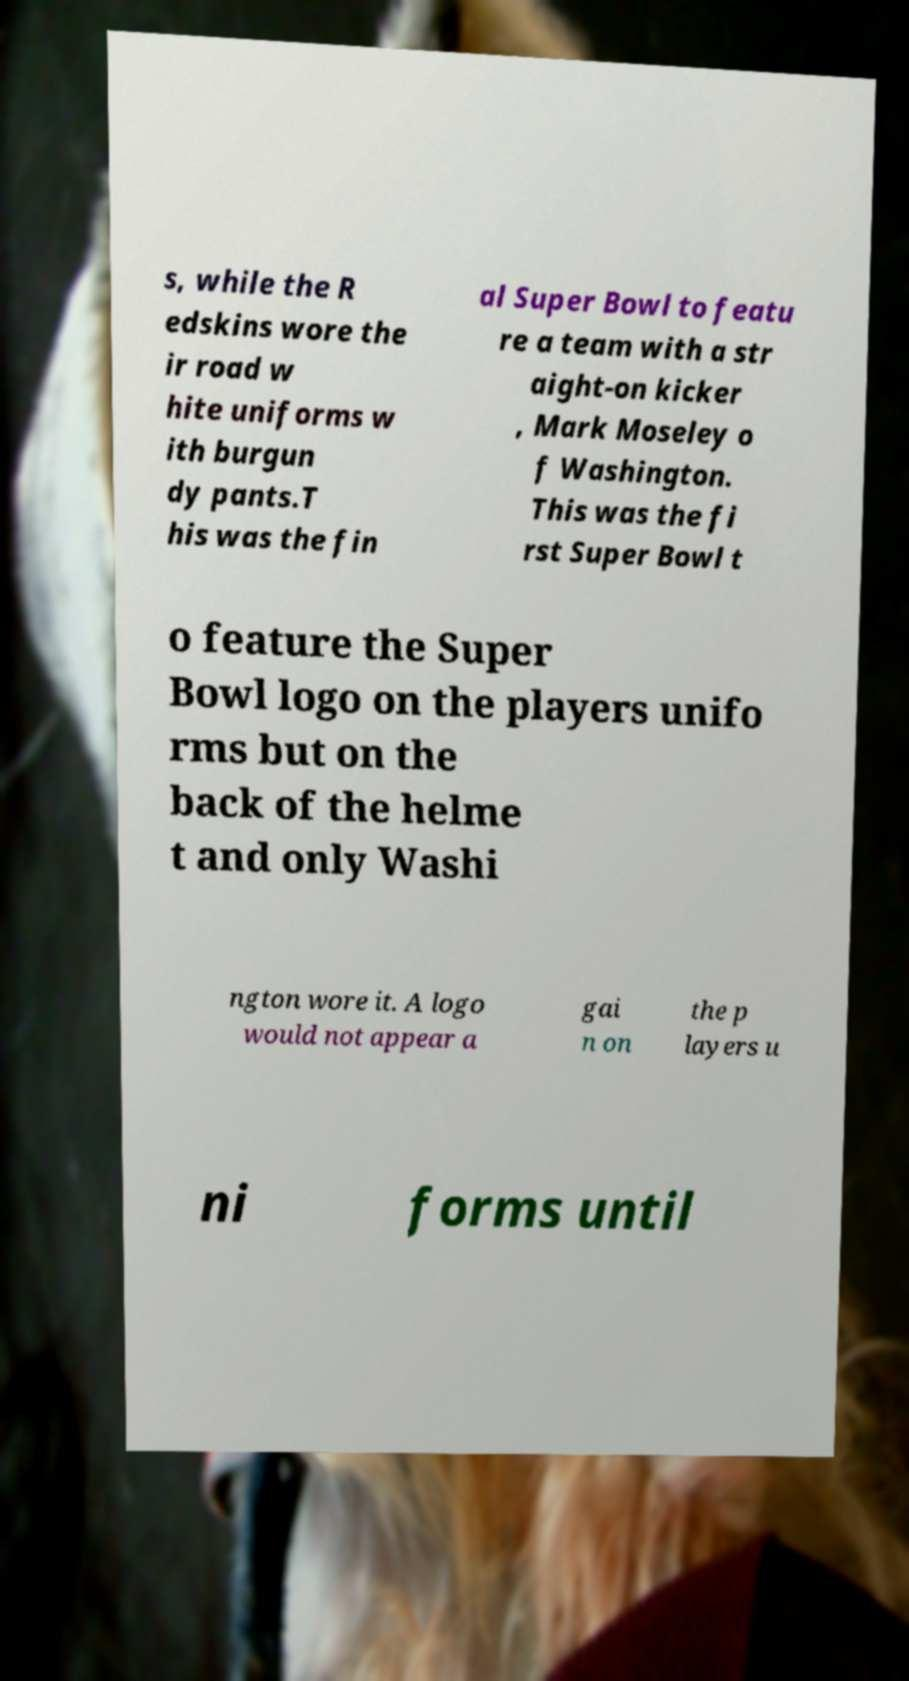Can you read and provide the text displayed in the image?This photo seems to have some interesting text. Can you extract and type it out for me? s, while the R edskins wore the ir road w hite uniforms w ith burgun dy pants.T his was the fin al Super Bowl to featu re a team with a str aight-on kicker , Mark Moseley o f Washington. This was the fi rst Super Bowl t o feature the Super Bowl logo on the players unifo rms but on the back of the helme t and only Washi ngton wore it. A logo would not appear a gai n on the p layers u ni forms until 